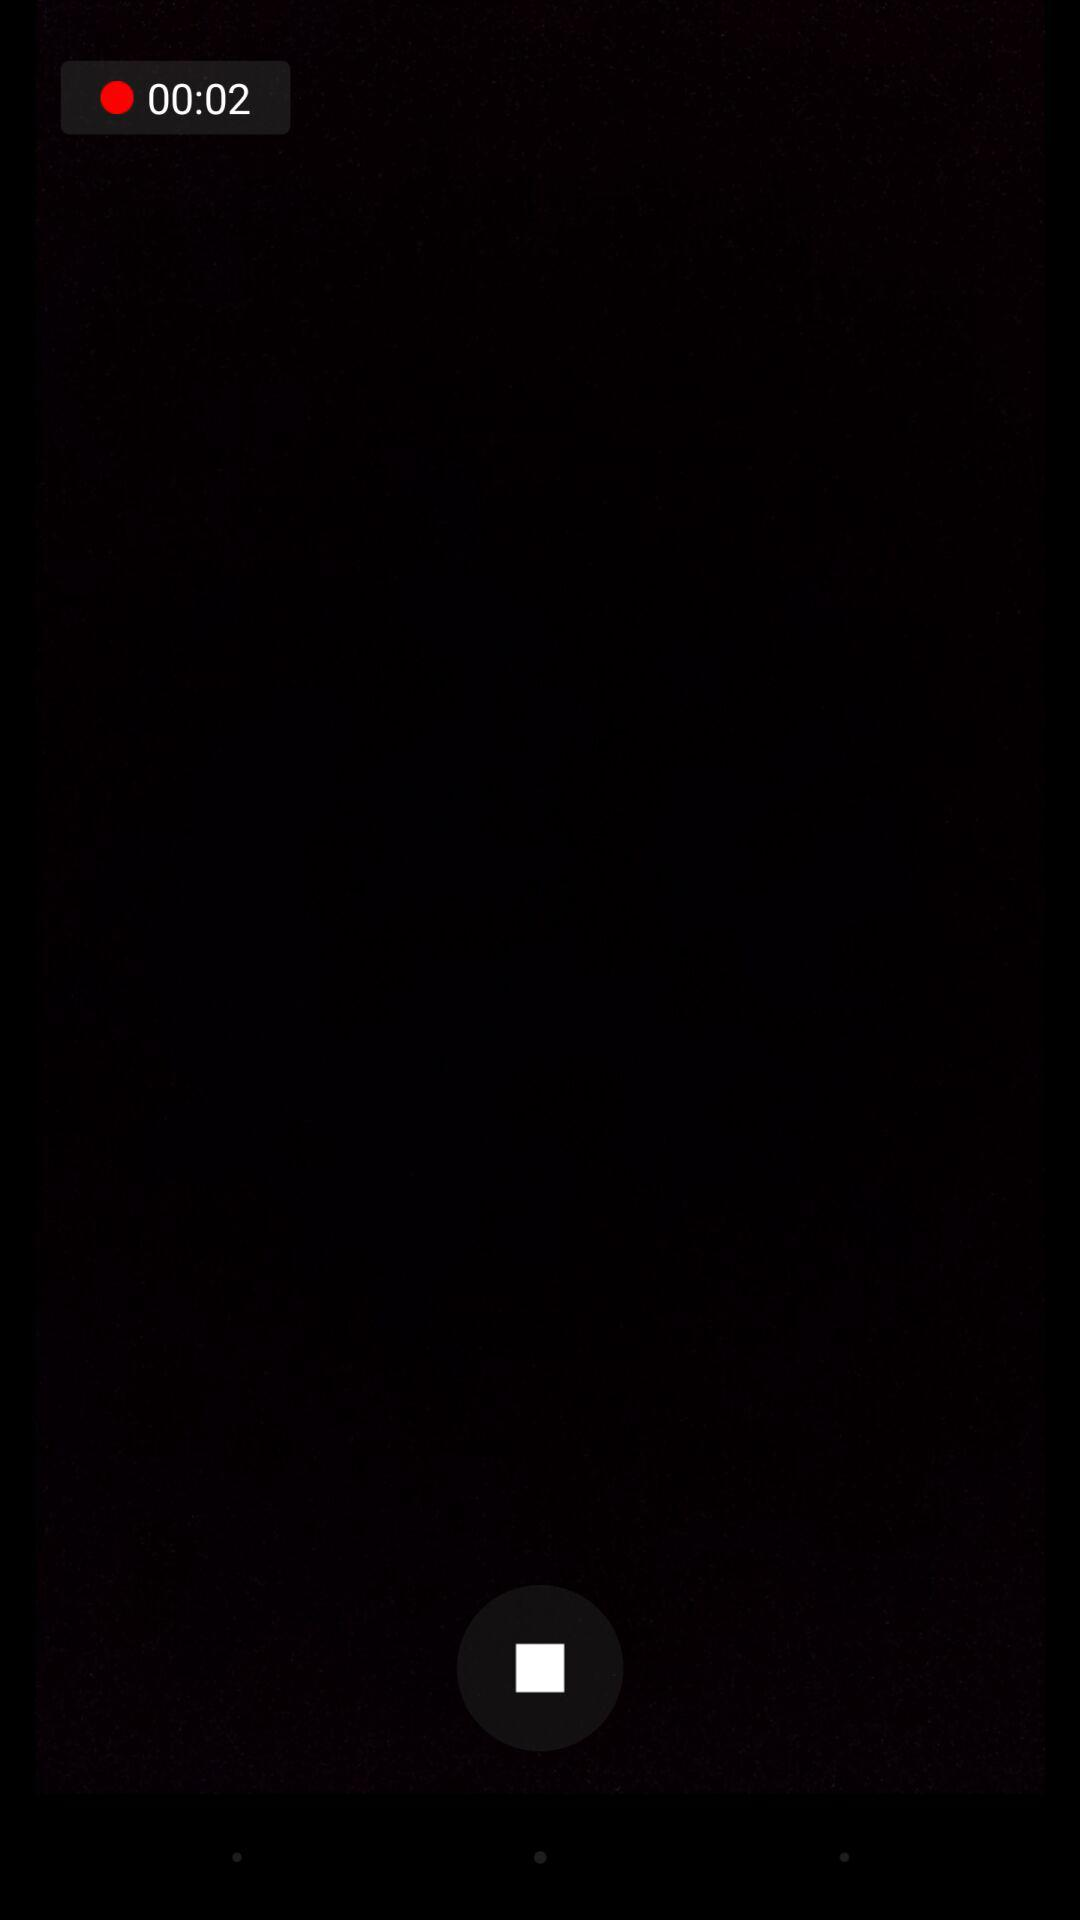How many seconds are left on the timer?
Answer the question using a single word or phrase. 2 